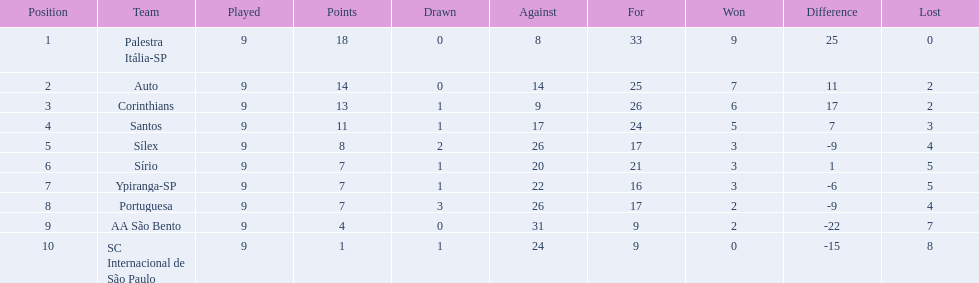What are all the teams? Palestra Itália-SP, Auto, Corinthians, Santos, Sílex, Sírio, Ypiranga-SP, Portuguesa, AA São Bento, SC Internacional de São Paulo. How many times did each team lose? 0, 2, 2, 3, 4, 5, 5, 4, 7, 8. And which team never lost? Palestra Itália-SP. 